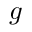<formula> <loc_0><loc_0><loc_500><loc_500>g</formula> 